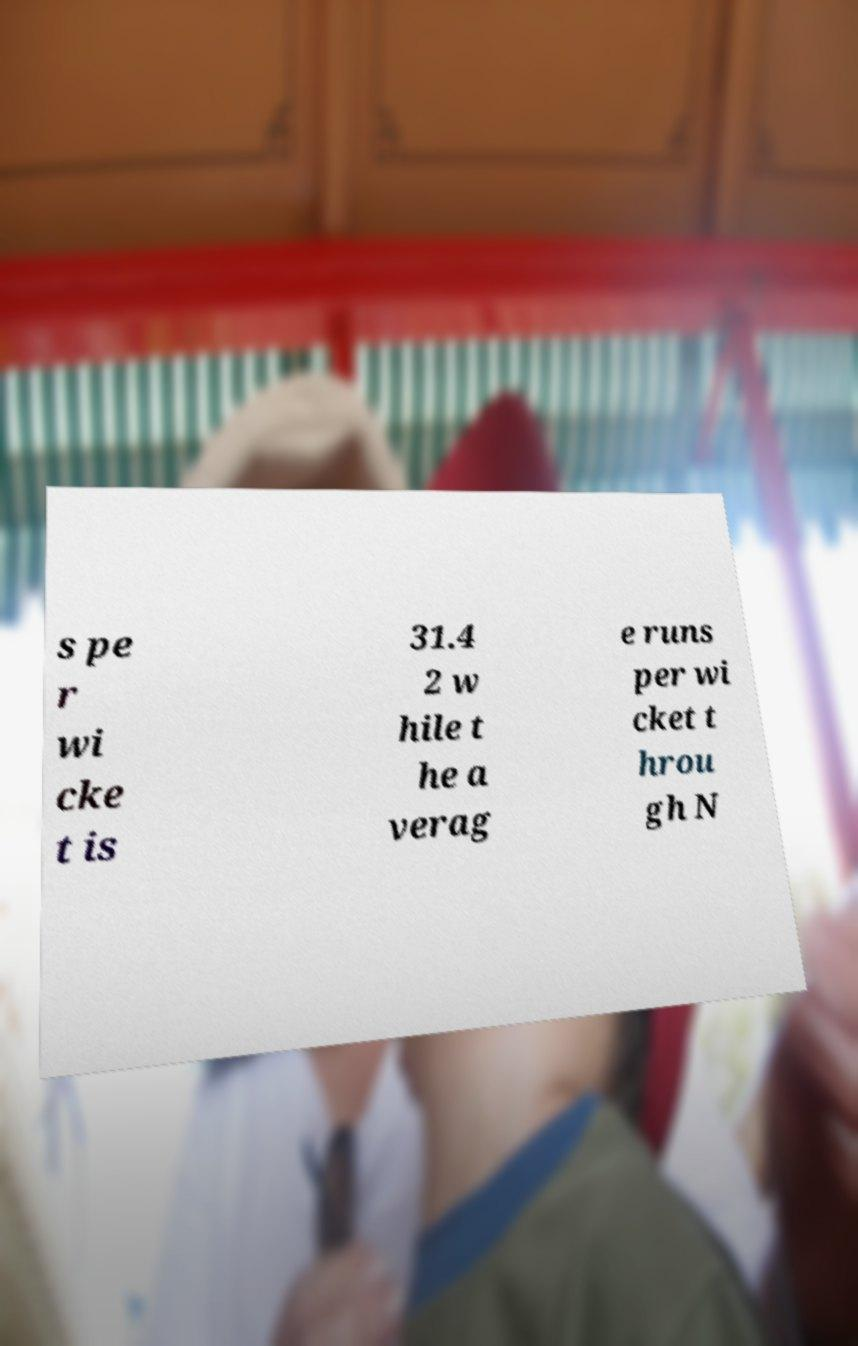Could you assist in decoding the text presented in this image and type it out clearly? s pe r wi cke t is 31.4 2 w hile t he a verag e runs per wi cket t hrou gh N 